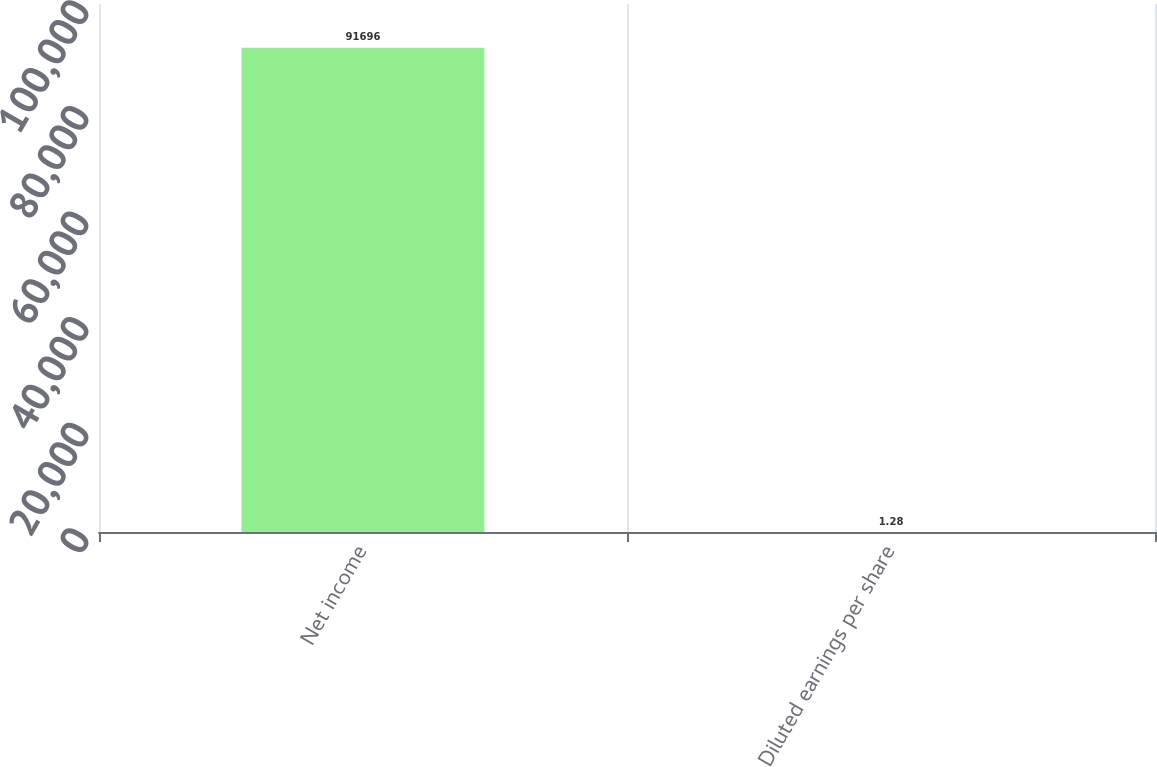<chart> <loc_0><loc_0><loc_500><loc_500><bar_chart><fcel>Net income<fcel>Diluted earnings per share<nl><fcel>91696<fcel>1.28<nl></chart> 